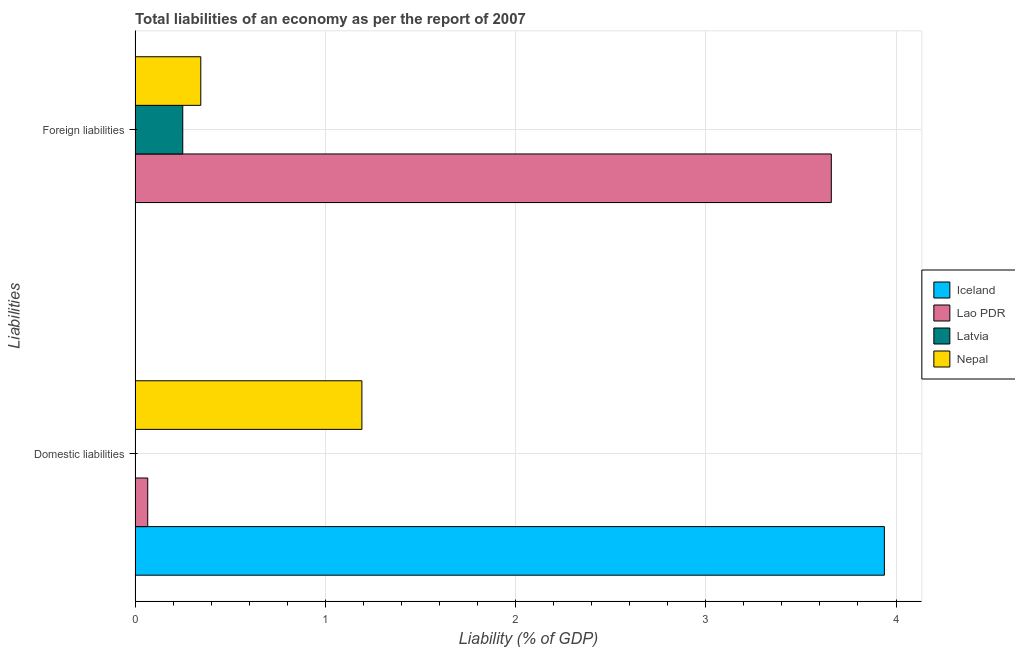Are the number of bars per tick equal to the number of legend labels?
Your answer should be very brief. No. Are the number of bars on each tick of the Y-axis equal?
Make the answer very short. Yes. How many bars are there on the 1st tick from the bottom?
Provide a succinct answer. 3. What is the label of the 1st group of bars from the top?
Provide a succinct answer. Foreign liabilities. What is the incurrence of domestic liabilities in Latvia?
Your response must be concise. 0. Across all countries, what is the maximum incurrence of foreign liabilities?
Provide a short and direct response. 3.66. Across all countries, what is the minimum incurrence of domestic liabilities?
Offer a terse response. 0. What is the total incurrence of foreign liabilities in the graph?
Ensure brevity in your answer.  4.26. What is the difference between the incurrence of foreign liabilities in Lao PDR and that in Latvia?
Your answer should be very brief. 3.41. What is the difference between the incurrence of domestic liabilities in Nepal and the incurrence of foreign liabilities in Lao PDR?
Offer a very short reply. -2.47. What is the average incurrence of domestic liabilities per country?
Provide a short and direct response. 1.3. What is the difference between the incurrence of foreign liabilities and incurrence of domestic liabilities in Nepal?
Your answer should be very brief. -0.85. In how many countries, is the incurrence of domestic liabilities greater than 0.6000000000000001 %?
Make the answer very short. 2. What is the ratio of the incurrence of foreign liabilities in Nepal to that in Lao PDR?
Your answer should be very brief. 0.09. Is the incurrence of domestic liabilities in Nepal less than that in Lao PDR?
Your response must be concise. No. In how many countries, is the incurrence of domestic liabilities greater than the average incurrence of domestic liabilities taken over all countries?
Offer a very short reply. 1. Are the values on the major ticks of X-axis written in scientific E-notation?
Offer a very short reply. No. How many legend labels are there?
Ensure brevity in your answer.  4. What is the title of the graph?
Provide a short and direct response. Total liabilities of an economy as per the report of 2007. What is the label or title of the X-axis?
Your response must be concise. Liability (% of GDP). What is the label or title of the Y-axis?
Offer a very short reply. Liabilities. What is the Liability (% of GDP) of Iceland in Domestic liabilities?
Offer a terse response. 3.94. What is the Liability (% of GDP) of Lao PDR in Domestic liabilities?
Offer a very short reply. 0.07. What is the Liability (% of GDP) of Nepal in Domestic liabilities?
Your answer should be compact. 1.19. What is the Liability (% of GDP) in Lao PDR in Foreign liabilities?
Ensure brevity in your answer.  3.66. What is the Liability (% of GDP) of Latvia in Foreign liabilities?
Keep it short and to the point. 0.25. What is the Liability (% of GDP) in Nepal in Foreign liabilities?
Give a very brief answer. 0.35. Across all Liabilities, what is the maximum Liability (% of GDP) of Iceland?
Offer a very short reply. 3.94. Across all Liabilities, what is the maximum Liability (% of GDP) in Lao PDR?
Provide a succinct answer. 3.66. Across all Liabilities, what is the maximum Liability (% of GDP) in Latvia?
Ensure brevity in your answer.  0.25. Across all Liabilities, what is the maximum Liability (% of GDP) in Nepal?
Make the answer very short. 1.19. Across all Liabilities, what is the minimum Liability (% of GDP) of Iceland?
Keep it short and to the point. 0. Across all Liabilities, what is the minimum Liability (% of GDP) of Lao PDR?
Make the answer very short. 0.07. Across all Liabilities, what is the minimum Liability (% of GDP) in Nepal?
Your answer should be very brief. 0.35. What is the total Liability (% of GDP) in Iceland in the graph?
Provide a succinct answer. 3.94. What is the total Liability (% of GDP) in Lao PDR in the graph?
Ensure brevity in your answer.  3.73. What is the total Liability (% of GDP) in Latvia in the graph?
Your answer should be very brief. 0.25. What is the total Liability (% of GDP) of Nepal in the graph?
Your answer should be very brief. 1.54. What is the difference between the Liability (% of GDP) of Lao PDR in Domestic liabilities and that in Foreign liabilities?
Your answer should be very brief. -3.59. What is the difference between the Liability (% of GDP) of Nepal in Domestic liabilities and that in Foreign liabilities?
Your answer should be very brief. 0.85. What is the difference between the Liability (% of GDP) in Iceland in Domestic liabilities and the Liability (% of GDP) in Lao PDR in Foreign liabilities?
Make the answer very short. 0.28. What is the difference between the Liability (% of GDP) of Iceland in Domestic liabilities and the Liability (% of GDP) of Latvia in Foreign liabilities?
Your response must be concise. 3.69. What is the difference between the Liability (% of GDP) in Iceland in Domestic liabilities and the Liability (% of GDP) in Nepal in Foreign liabilities?
Provide a succinct answer. 3.59. What is the difference between the Liability (% of GDP) in Lao PDR in Domestic liabilities and the Liability (% of GDP) in Latvia in Foreign liabilities?
Your response must be concise. -0.18. What is the difference between the Liability (% of GDP) of Lao PDR in Domestic liabilities and the Liability (% of GDP) of Nepal in Foreign liabilities?
Your response must be concise. -0.28. What is the average Liability (% of GDP) in Iceland per Liabilities?
Give a very brief answer. 1.97. What is the average Liability (% of GDP) in Lao PDR per Liabilities?
Ensure brevity in your answer.  1.86. What is the average Liability (% of GDP) of Latvia per Liabilities?
Your response must be concise. 0.13. What is the average Liability (% of GDP) in Nepal per Liabilities?
Give a very brief answer. 0.77. What is the difference between the Liability (% of GDP) in Iceland and Liability (% of GDP) in Lao PDR in Domestic liabilities?
Your response must be concise. 3.87. What is the difference between the Liability (% of GDP) in Iceland and Liability (% of GDP) in Nepal in Domestic liabilities?
Ensure brevity in your answer.  2.75. What is the difference between the Liability (% of GDP) in Lao PDR and Liability (% of GDP) in Nepal in Domestic liabilities?
Your answer should be very brief. -1.13. What is the difference between the Liability (% of GDP) of Lao PDR and Liability (% of GDP) of Latvia in Foreign liabilities?
Your answer should be compact. 3.41. What is the difference between the Liability (% of GDP) of Lao PDR and Liability (% of GDP) of Nepal in Foreign liabilities?
Offer a terse response. 3.31. What is the difference between the Liability (% of GDP) of Latvia and Liability (% of GDP) of Nepal in Foreign liabilities?
Ensure brevity in your answer.  -0.09. What is the ratio of the Liability (% of GDP) in Lao PDR in Domestic liabilities to that in Foreign liabilities?
Your answer should be very brief. 0.02. What is the ratio of the Liability (% of GDP) of Nepal in Domestic liabilities to that in Foreign liabilities?
Your answer should be very brief. 3.45. What is the difference between the highest and the second highest Liability (% of GDP) of Lao PDR?
Make the answer very short. 3.59. What is the difference between the highest and the second highest Liability (% of GDP) of Nepal?
Provide a succinct answer. 0.85. What is the difference between the highest and the lowest Liability (% of GDP) of Iceland?
Make the answer very short. 3.94. What is the difference between the highest and the lowest Liability (% of GDP) in Lao PDR?
Offer a terse response. 3.59. What is the difference between the highest and the lowest Liability (% of GDP) in Latvia?
Ensure brevity in your answer.  0.25. What is the difference between the highest and the lowest Liability (% of GDP) of Nepal?
Give a very brief answer. 0.85. 